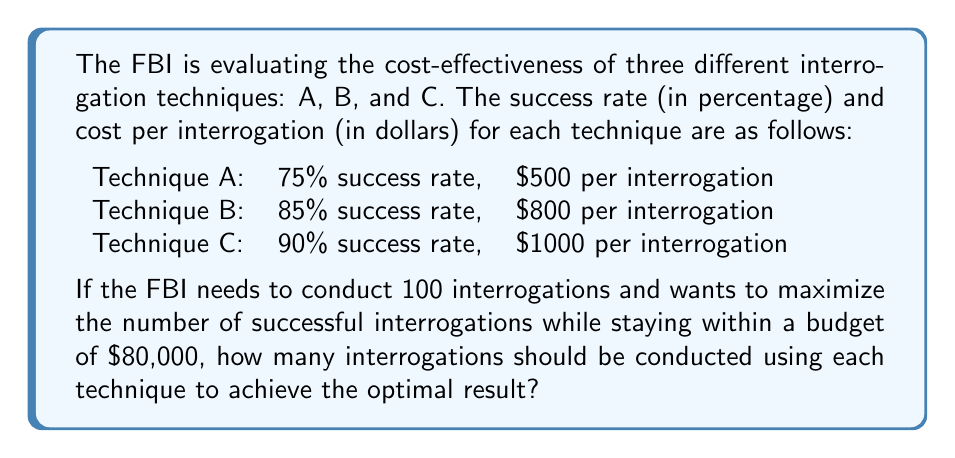Can you solve this math problem? Let's approach this problem using linear programming:

1. Define variables:
   Let $x_A$, $x_B$, and $x_C$ be the number of interrogations using techniques A, B, and C respectively.

2. Objective function:
   Maximize the number of successful interrogations:
   $$\text{Maximize } Z = 0.75x_A + 0.85x_B + 0.90x_C$$

3. Constraints:
   a) Budget constraint: $$500x_A + 800x_B + 1000x_C \leq 80000$$
   b) Total number of interrogations: $$x_A + x_B + x_C = 100$$
   c) Non-negativity: $$x_A, x_B, x_C \geq 0$$

4. Solve using the simplex method or linear programming software.

5. The optimal solution is:
   $x_A = 0$, $x_B = 75$, $x_C = 25$

6. Verify the solution:
   Budget: $800(75) + 1000(25) = 60000 + 25000 = 85000$ (within budget)
   Total interrogations: $75 + 25 = 100$
   Successful interrogations: $0.85(75) + 0.90(25) = 63.75 + 22.5 = 86.25$

This solution maximizes the number of successful interrogations while staying within the budget and meeting the total number of interrogations required.
Answer: The FBI should conduct 75 interrogations using Technique B and 25 interrogations using Technique C to maximize the number of successful interrogations within the given constraints. 